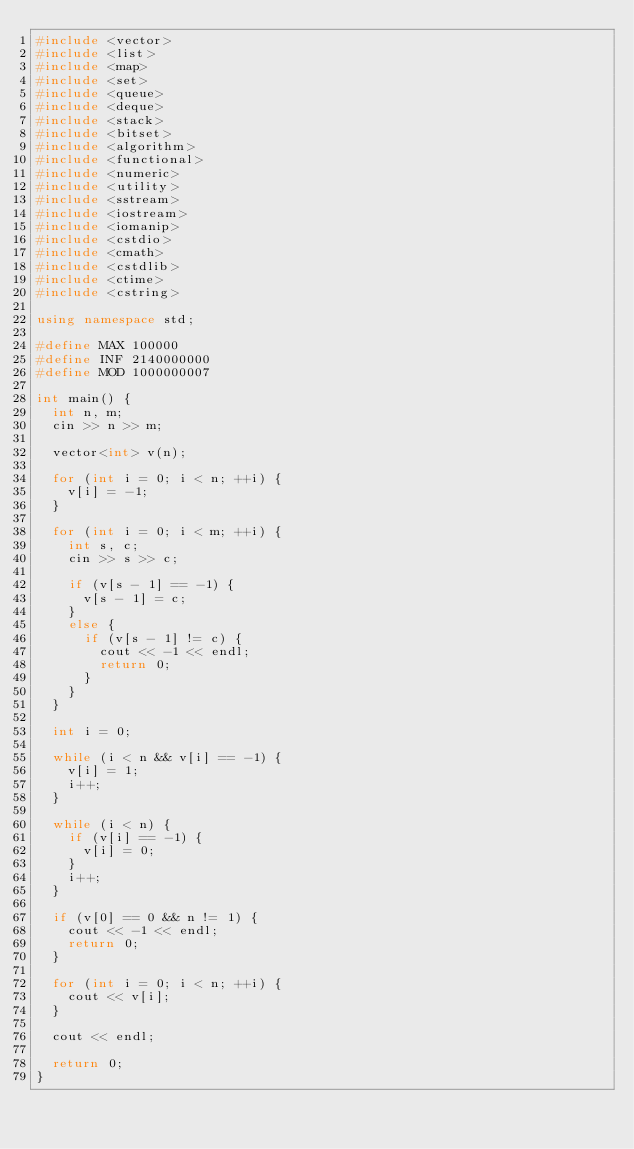<code> <loc_0><loc_0><loc_500><loc_500><_C++_>#include <vector>
#include <list>
#include <map>
#include <set>
#include <queue>
#include <deque>
#include <stack>
#include <bitset>
#include <algorithm>
#include <functional>
#include <numeric>
#include <utility>
#include <sstream>
#include <iostream>
#include <iomanip>
#include <cstdio>
#include <cmath>
#include <cstdlib>
#include <ctime>
#include <cstring>

using namespace std;

#define MAX 100000
#define INF 2140000000
#define MOD 1000000007

int main() {
	int n, m;
	cin >> n >> m;

	vector<int> v(n);

	for (int i = 0; i < n; ++i) {
		v[i] = -1;
	}

	for (int i = 0; i < m; ++i) {
		int s, c;
		cin >> s >> c;

		if (v[s - 1] == -1) {
			v[s - 1] = c;
		}
		else {
			if (v[s - 1] != c) {
				cout << -1 << endl;
				return 0;
			}
		}
	}

	int i = 0;

	while (i < n && v[i] == -1) {
		v[i] = 1;
		i++;
	}

	while (i < n) {
		if (v[i] == -1) {
			v[i] = 0;
		}
		i++;
	}

	if (v[0] == 0 && n != 1) {
		cout << -1 << endl;
		return 0;
	}

	for (int i = 0; i < n; ++i) {
		cout << v[i];
	}

	cout << endl;

	return 0;
}</code> 